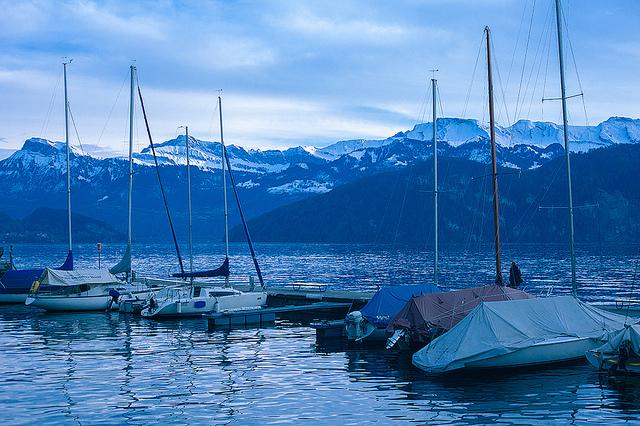Are these boats in danger of capsizing?
Concise answer only. No. How many covered boats are there?
Be succinct. 5. Are these sailboats?
Write a very short answer. Yes. 